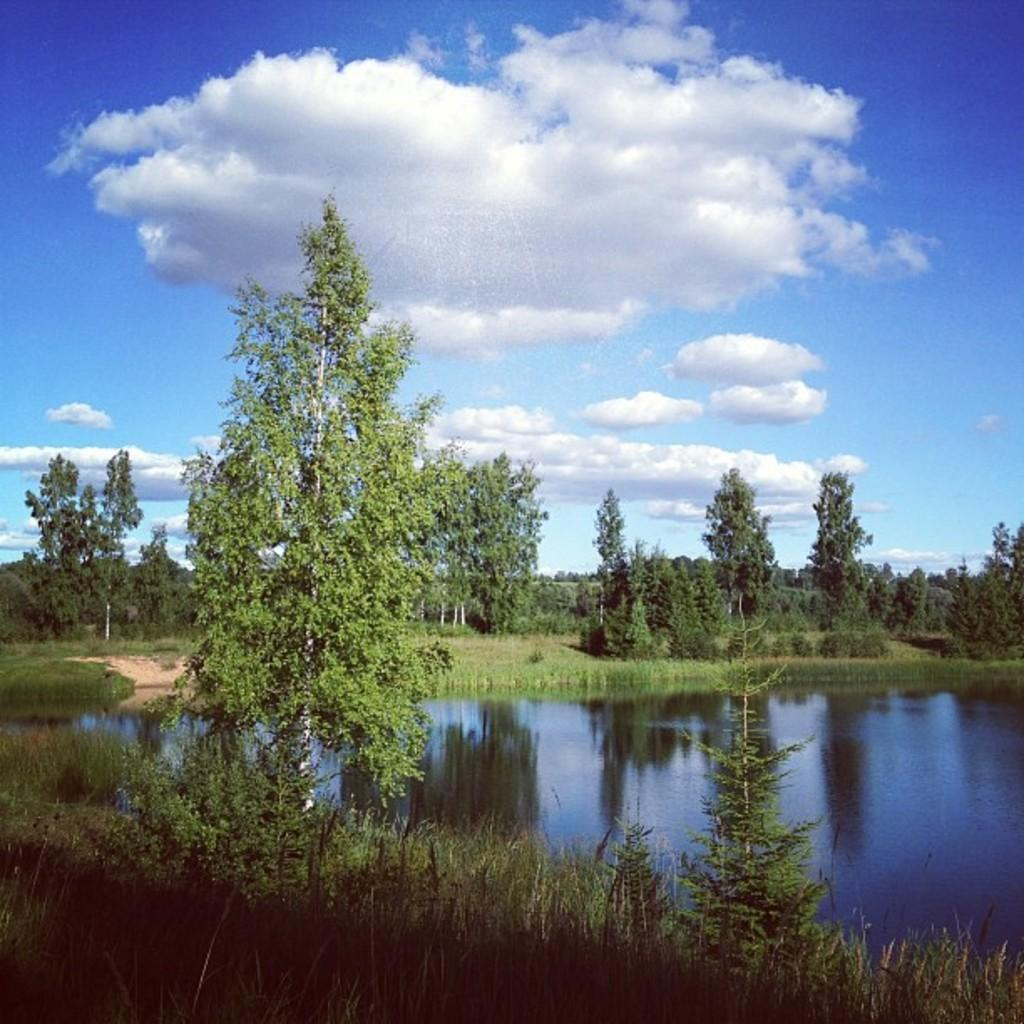What is the main feature in the center of the image? There is a pond in the center of the image. What can be seen in the background of the image? There are trees and the sky visible in the background of the image. What type of vegetation is at the bottom of the image? There is grass at the bottom of the image. What is the name of the cream that is floating on the pond in the image? There is no cream floating on the pond in the image. 